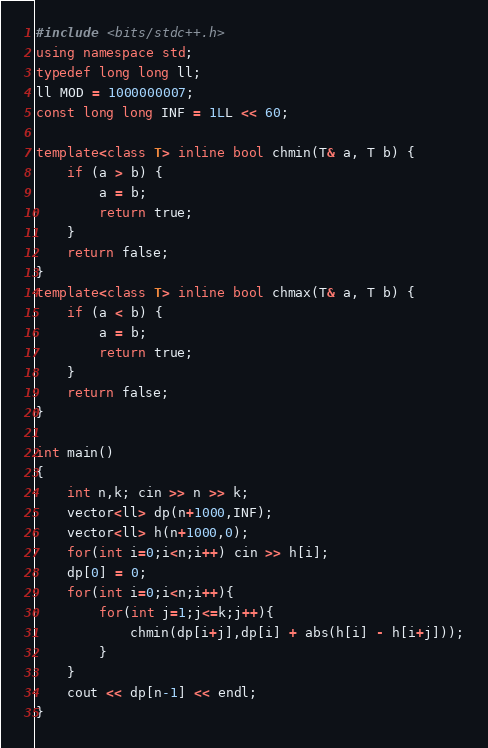Convert code to text. <code><loc_0><loc_0><loc_500><loc_500><_C++_>#include <bits/stdc++.h>
using namespace std;
typedef long long ll;
ll MOD = 1000000007;
const long long INF = 1LL << 60;

template<class T> inline bool chmin(T& a, T b) {
    if (a > b) {
        a = b;
        return true;
    }
    return false;
}
template<class T> inline bool chmax(T& a, T b) {
    if (a < b) {
        a = b;
        return true;
    }
    return false;
}

int main()
{
    int n,k; cin >> n >> k;
    vector<ll> dp(n+1000,INF);
    vector<ll> h(n+1000,0);
    for(int i=0;i<n;i++) cin >> h[i];
    dp[0] = 0;
    for(int i=0;i<n;i++){
        for(int j=1;j<=k;j++){
            chmin(dp[i+j],dp[i] + abs(h[i] - h[i+j]));
        }
    }
    cout << dp[n-1] << endl;
}</code> 